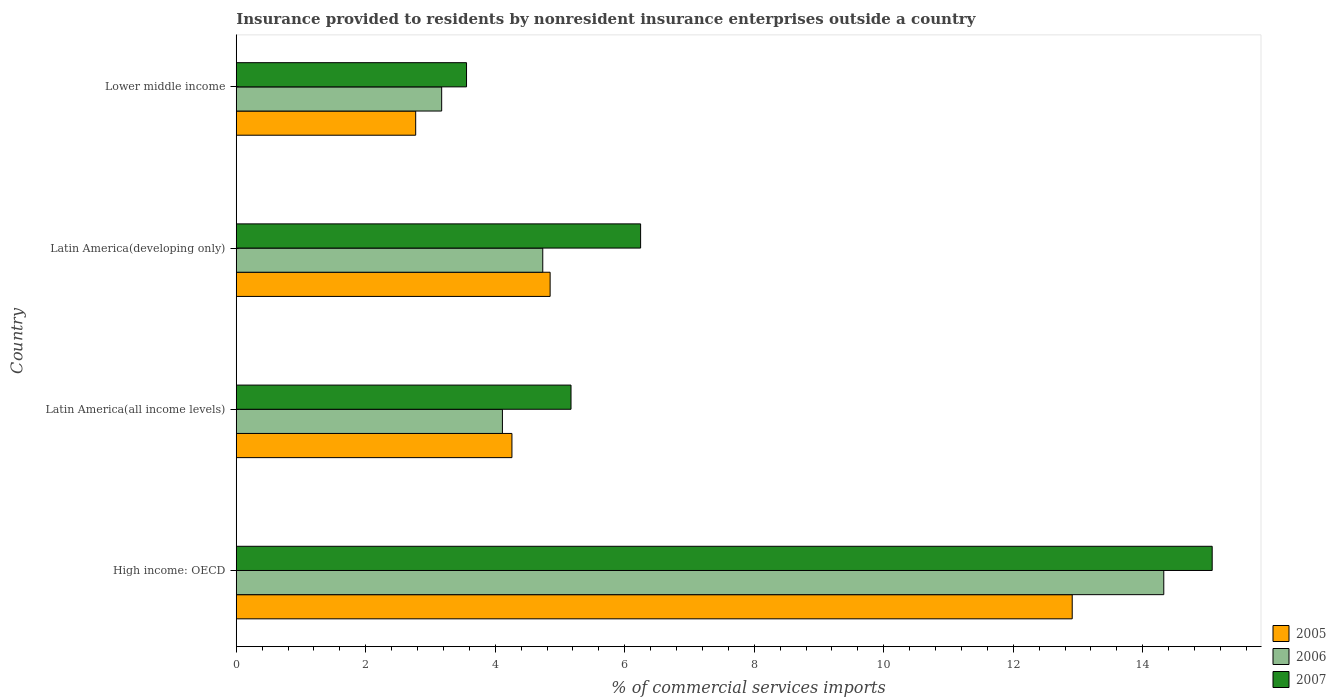How many different coloured bars are there?
Make the answer very short. 3. How many groups of bars are there?
Give a very brief answer. 4. Are the number of bars per tick equal to the number of legend labels?
Provide a short and direct response. Yes. Are the number of bars on each tick of the Y-axis equal?
Offer a very short reply. Yes. How many bars are there on the 2nd tick from the top?
Offer a terse response. 3. How many bars are there on the 1st tick from the bottom?
Your answer should be compact. 3. What is the label of the 1st group of bars from the top?
Your response must be concise. Lower middle income. What is the Insurance provided to residents in 2005 in Latin America(all income levels)?
Make the answer very short. 4.26. Across all countries, what is the maximum Insurance provided to residents in 2006?
Your answer should be very brief. 14.33. Across all countries, what is the minimum Insurance provided to residents in 2007?
Offer a terse response. 3.56. In which country was the Insurance provided to residents in 2005 maximum?
Provide a succinct answer. High income: OECD. In which country was the Insurance provided to residents in 2005 minimum?
Provide a succinct answer. Lower middle income. What is the total Insurance provided to residents in 2007 in the graph?
Provide a short and direct response. 30.04. What is the difference between the Insurance provided to residents in 2005 in High income: OECD and that in Latin America(all income levels)?
Offer a terse response. 8.65. What is the difference between the Insurance provided to residents in 2006 in Latin America(all income levels) and the Insurance provided to residents in 2007 in Latin America(developing only)?
Provide a succinct answer. -2.13. What is the average Insurance provided to residents in 2007 per country?
Make the answer very short. 7.51. What is the difference between the Insurance provided to residents in 2006 and Insurance provided to residents in 2007 in Latin America(all income levels)?
Provide a short and direct response. -1.06. In how many countries, is the Insurance provided to residents in 2006 greater than 6.4 %?
Provide a short and direct response. 1. What is the ratio of the Insurance provided to residents in 2005 in High income: OECD to that in Lower middle income?
Keep it short and to the point. 4.66. What is the difference between the highest and the second highest Insurance provided to residents in 2007?
Ensure brevity in your answer.  8.83. What is the difference between the highest and the lowest Insurance provided to residents in 2006?
Provide a short and direct response. 11.15. What does the 2nd bar from the bottom in Latin America(developing only) represents?
Your response must be concise. 2006. Is it the case that in every country, the sum of the Insurance provided to residents in 2006 and Insurance provided to residents in 2007 is greater than the Insurance provided to residents in 2005?
Ensure brevity in your answer.  Yes. How many bars are there?
Your answer should be very brief. 12. Are all the bars in the graph horizontal?
Your answer should be compact. Yes. How many countries are there in the graph?
Provide a short and direct response. 4. Does the graph contain any zero values?
Offer a very short reply. No. Where does the legend appear in the graph?
Offer a terse response. Bottom right. How many legend labels are there?
Give a very brief answer. 3. How are the legend labels stacked?
Ensure brevity in your answer.  Vertical. What is the title of the graph?
Your answer should be compact. Insurance provided to residents by nonresident insurance enterprises outside a country. What is the label or title of the X-axis?
Provide a short and direct response. % of commercial services imports. What is the % of commercial services imports in 2005 in High income: OECD?
Provide a succinct answer. 12.91. What is the % of commercial services imports in 2006 in High income: OECD?
Ensure brevity in your answer.  14.33. What is the % of commercial services imports in 2007 in High income: OECD?
Keep it short and to the point. 15.07. What is the % of commercial services imports of 2005 in Latin America(all income levels)?
Give a very brief answer. 4.26. What is the % of commercial services imports of 2006 in Latin America(all income levels)?
Keep it short and to the point. 4.11. What is the % of commercial services imports in 2007 in Latin America(all income levels)?
Provide a short and direct response. 5.17. What is the % of commercial services imports of 2005 in Latin America(developing only)?
Your answer should be compact. 4.85. What is the % of commercial services imports in 2006 in Latin America(developing only)?
Provide a short and direct response. 4.73. What is the % of commercial services imports of 2007 in Latin America(developing only)?
Make the answer very short. 6.25. What is the % of commercial services imports in 2005 in Lower middle income?
Provide a succinct answer. 2.77. What is the % of commercial services imports in 2006 in Lower middle income?
Offer a terse response. 3.17. What is the % of commercial services imports of 2007 in Lower middle income?
Offer a terse response. 3.56. Across all countries, what is the maximum % of commercial services imports in 2005?
Give a very brief answer. 12.91. Across all countries, what is the maximum % of commercial services imports of 2006?
Provide a short and direct response. 14.33. Across all countries, what is the maximum % of commercial services imports of 2007?
Your answer should be compact. 15.07. Across all countries, what is the minimum % of commercial services imports of 2005?
Your response must be concise. 2.77. Across all countries, what is the minimum % of commercial services imports of 2006?
Provide a succinct answer. 3.17. Across all countries, what is the minimum % of commercial services imports of 2007?
Provide a succinct answer. 3.56. What is the total % of commercial services imports in 2005 in the graph?
Provide a short and direct response. 24.79. What is the total % of commercial services imports in 2006 in the graph?
Offer a very short reply. 26.34. What is the total % of commercial services imports of 2007 in the graph?
Give a very brief answer. 30.04. What is the difference between the % of commercial services imports in 2005 in High income: OECD and that in Latin America(all income levels)?
Give a very brief answer. 8.65. What is the difference between the % of commercial services imports in 2006 in High income: OECD and that in Latin America(all income levels)?
Keep it short and to the point. 10.21. What is the difference between the % of commercial services imports of 2007 in High income: OECD and that in Latin America(all income levels)?
Make the answer very short. 9.9. What is the difference between the % of commercial services imports of 2005 in High income: OECD and that in Latin America(developing only)?
Your answer should be very brief. 8.06. What is the difference between the % of commercial services imports in 2006 in High income: OECD and that in Latin America(developing only)?
Provide a succinct answer. 9.59. What is the difference between the % of commercial services imports in 2007 in High income: OECD and that in Latin America(developing only)?
Provide a short and direct response. 8.83. What is the difference between the % of commercial services imports of 2005 in High income: OECD and that in Lower middle income?
Provide a succinct answer. 10.14. What is the difference between the % of commercial services imports in 2006 in High income: OECD and that in Lower middle income?
Provide a succinct answer. 11.15. What is the difference between the % of commercial services imports of 2007 in High income: OECD and that in Lower middle income?
Keep it short and to the point. 11.52. What is the difference between the % of commercial services imports in 2005 in Latin America(all income levels) and that in Latin America(developing only)?
Offer a very short reply. -0.59. What is the difference between the % of commercial services imports of 2006 in Latin America(all income levels) and that in Latin America(developing only)?
Offer a very short reply. -0.62. What is the difference between the % of commercial services imports in 2007 in Latin America(all income levels) and that in Latin America(developing only)?
Keep it short and to the point. -1.07. What is the difference between the % of commercial services imports of 2005 in Latin America(all income levels) and that in Lower middle income?
Give a very brief answer. 1.49. What is the difference between the % of commercial services imports of 2006 in Latin America(all income levels) and that in Lower middle income?
Give a very brief answer. 0.94. What is the difference between the % of commercial services imports in 2007 in Latin America(all income levels) and that in Lower middle income?
Your answer should be compact. 1.61. What is the difference between the % of commercial services imports of 2005 in Latin America(developing only) and that in Lower middle income?
Offer a terse response. 2.08. What is the difference between the % of commercial services imports of 2006 in Latin America(developing only) and that in Lower middle income?
Provide a succinct answer. 1.56. What is the difference between the % of commercial services imports in 2007 in Latin America(developing only) and that in Lower middle income?
Your answer should be very brief. 2.69. What is the difference between the % of commercial services imports in 2005 in High income: OECD and the % of commercial services imports in 2006 in Latin America(all income levels)?
Offer a terse response. 8.8. What is the difference between the % of commercial services imports of 2005 in High income: OECD and the % of commercial services imports of 2007 in Latin America(all income levels)?
Keep it short and to the point. 7.74. What is the difference between the % of commercial services imports in 2006 in High income: OECD and the % of commercial services imports in 2007 in Latin America(all income levels)?
Your answer should be very brief. 9.15. What is the difference between the % of commercial services imports in 2005 in High income: OECD and the % of commercial services imports in 2006 in Latin America(developing only)?
Your answer should be very brief. 8.18. What is the difference between the % of commercial services imports of 2005 in High income: OECD and the % of commercial services imports of 2007 in Latin America(developing only)?
Your answer should be compact. 6.67. What is the difference between the % of commercial services imports in 2006 in High income: OECD and the % of commercial services imports in 2007 in Latin America(developing only)?
Offer a terse response. 8.08. What is the difference between the % of commercial services imports of 2005 in High income: OECD and the % of commercial services imports of 2006 in Lower middle income?
Ensure brevity in your answer.  9.74. What is the difference between the % of commercial services imports in 2005 in High income: OECD and the % of commercial services imports in 2007 in Lower middle income?
Provide a succinct answer. 9.35. What is the difference between the % of commercial services imports of 2006 in High income: OECD and the % of commercial services imports of 2007 in Lower middle income?
Ensure brevity in your answer.  10.77. What is the difference between the % of commercial services imports in 2005 in Latin America(all income levels) and the % of commercial services imports in 2006 in Latin America(developing only)?
Your answer should be very brief. -0.48. What is the difference between the % of commercial services imports of 2005 in Latin America(all income levels) and the % of commercial services imports of 2007 in Latin America(developing only)?
Offer a very short reply. -1.99. What is the difference between the % of commercial services imports in 2006 in Latin America(all income levels) and the % of commercial services imports in 2007 in Latin America(developing only)?
Give a very brief answer. -2.13. What is the difference between the % of commercial services imports of 2005 in Latin America(all income levels) and the % of commercial services imports of 2006 in Lower middle income?
Provide a short and direct response. 1.08. What is the difference between the % of commercial services imports in 2005 in Latin America(all income levels) and the % of commercial services imports in 2007 in Lower middle income?
Keep it short and to the point. 0.7. What is the difference between the % of commercial services imports of 2006 in Latin America(all income levels) and the % of commercial services imports of 2007 in Lower middle income?
Offer a very short reply. 0.55. What is the difference between the % of commercial services imports in 2005 in Latin America(developing only) and the % of commercial services imports in 2006 in Lower middle income?
Keep it short and to the point. 1.67. What is the difference between the % of commercial services imports of 2005 in Latin America(developing only) and the % of commercial services imports of 2007 in Lower middle income?
Make the answer very short. 1.29. What is the difference between the % of commercial services imports of 2006 in Latin America(developing only) and the % of commercial services imports of 2007 in Lower middle income?
Your answer should be compact. 1.18. What is the average % of commercial services imports in 2005 per country?
Your response must be concise. 6.2. What is the average % of commercial services imports in 2006 per country?
Offer a terse response. 6.59. What is the average % of commercial services imports in 2007 per country?
Your response must be concise. 7.51. What is the difference between the % of commercial services imports in 2005 and % of commercial services imports in 2006 in High income: OECD?
Your answer should be very brief. -1.41. What is the difference between the % of commercial services imports of 2005 and % of commercial services imports of 2007 in High income: OECD?
Give a very brief answer. -2.16. What is the difference between the % of commercial services imports of 2006 and % of commercial services imports of 2007 in High income: OECD?
Make the answer very short. -0.75. What is the difference between the % of commercial services imports in 2005 and % of commercial services imports in 2006 in Latin America(all income levels)?
Your answer should be very brief. 0.15. What is the difference between the % of commercial services imports of 2005 and % of commercial services imports of 2007 in Latin America(all income levels)?
Ensure brevity in your answer.  -0.91. What is the difference between the % of commercial services imports of 2006 and % of commercial services imports of 2007 in Latin America(all income levels)?
Give a very brief answer. -1.06. What is the difference between the % of commercial services imports of 2005 and % of commercial services imports of 2006 in Latin America(developing only)?
Your response must be concise. 0.11. What is the difference between the % of commercial services imports of 2005 and % of commercial services imports of 2007 in Latin America(developing only)?
Your response must be concise. -1.4. What is the difference between the % of commercial services imports in 2006 and % of commercial services imports in 2007 in Latin America(developing only)?
Ensure brevity in your answer.  -1.51. What is the difference between the % of commercial services imports in 2005 and % of commercial services imports in 2006 in Lower middle income?
Make the answer very short. -0.4. What is the difference between the % of commercial services imports in 2005 and % of commercial services imports in 2007 in Lower middle income?
Make the answer very short. -0.79. What is the difference between the % of commercial services imports of 2006 and % of commercial services imports of 2007 in Lower middle income?
Give a very brief answer. -0.38. What is the ratio of the % of commercial services imports in 2005 in High income: OECD to that in Latin America(all income levels)?
Your answer should be very brief. 3.03. What is the ratio of the % of commercial services imports of 2006 in High income: OECD to that in Latin America(all income levels)?
Offer a very short reply. 3.48. What is the ratio of the % of commercial services imports in 2007 in High income: OECD to that in Latin America(all income levels)?
Make the answer very short. 2.92. What is the ratio of the % of commercial services imports in 2005 in High income: OECD to that in Latin America(developing only)?
Your response must be concise. 2.66. What is the ratio of the % of commercial services imports in 2006 in High income: OECD to that in Latin America(developing only)?
Keep it short and to the point. 3.03. What is the ratio of the % of commercial services imports in 2007 in High income: OECD to that in Latin America(developing only)?
Keep it short and to the point. 2.41. What is the ratio of the % of commercial services imports of 2005 in High income: OECD to that in Lower middle income?
Your response must be concise. 4.66. What is the ratio of the % of commercial services imports of 2006 in High income: OECD to that in Lower middle income?
Your response must be concise. 4.52. What is the ratio of the % of commercial services imports of 2007 in High income: OECD to that in Lower middle income?
Offer a very short reply. 4.24. What is the ratio of the % of commercial services imports of 2005 in Latin America(all income levels) to that in Latin America(developing only)?
Ensure brevity in your answer.  0.88. What is the ratio of the % of commercial services imports of 2006 in Latin America(all income levels) to that in Latin America(developing only)?
Make the answer very short. 0.87. What is the ratio of the % of commercial services imports of 2007 in Latin America(all income levels) to that in Latin America(developing only)?
Your answer should be compact. 0.83. What is the ratio of the % of commercial services imports in 2005 in Latin America(all income levels) to that in Lower middle income?
Provide a short and direct response. 1.54. What is the ratio of the % of commercial services imports of 2006 in Latin America(all income levels) to that in Lower middle income?
Make the answer very short. 1.3. What is the ratio of the % of commercial services imports in 2007 in Latin America(all income levels) to that in Lower middle income?
Your answer should be compact. 1.45. What is the ratio of the % of commercial services imports of 2005 in Latin America(developing only) to that in Lower middle income?
Your answer should be compact. 1.75. What is the ratio of the % of commercial services imports of 2006 in Latin America(developing only) to that in Lower middle income?
Make the answer very short. 1.49. What is the ratio of the % of commercial services imports of 2007 in Latin America(developing only) to that in Lower middle income?
Ensure brevity in your answer.  1.76. What is the difference between the highest and the second highest % of commercial services imports of 2005?
Make the answer very short. 8.06. What is the difference between the highest and the second highest % of commercial services imports in 2006?
Provide a short and direct response. 9.59. What is the difference between the highest and the second highest % of commercial services imports of 2007?
Give a very brief answer. 8.83. What is the difference between the highest and the lowest % of commercial services imports in 2005?
Provide a succinct answer. 10.14. What is the difference between the highest and the lowest % of commercial services imports in 2006?
Offer a very short reply. 11.15. What is the difference between the highest and the lowest % of commercial services imports of 2007?
Your answer should be compact. 11.52. 